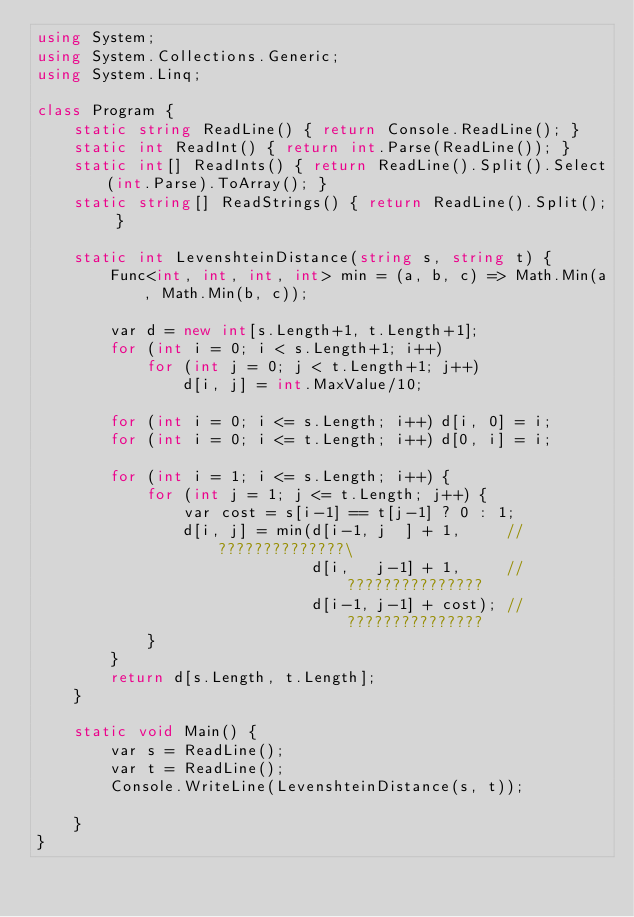<code> <loc_0><loc_0><loc_500><loc_500><_C#_>using System;
using System.Collections.Generic;
using System.Linq;

class Program {
    static string ReadLine() { return Console.ReadLine(); }
    static int ReadInt() { return int.Parse(ReadLine()); }
    static int[] ReadInts() { return ReadLine().Split().Select(int.Parse).ToArray(); }
    static string[] ReadStrings() { return ReadLine().Split(); }

    static int LevenshteinDistance(string s, string t) {
        Func<int, int, int, int> min = (a, b, c) => Math.Min(a, Math.Min(b, c));

        var d = new int[s.Length+1, t.Length+1];
        for (int i = 0; i < s.Length+1; i++)
            for (int j = 0; j < t.Length+1; j++)
                d[i, j] = int.MaxValue/10;

        for (int i = 0; i <= s.Length; i++) d[i, 0] = i;
        for (int i = 0; i <= t.Length; i++) d[0, i] = i;

        for (int i = 1; i <= s.Length; i++) {
            for (int j = 1; j <= t.Length; j++) {
                var cost = s[i-1] == t[j-1] ? 0 : 1;
                d[i, j] = min(d[i-1, j  ] + 1,     // ??????????????\
                              d[i,   j-1] + 1,     // ???????????????
                              d[i-1, j-1] + cost); // ???????????????
            }
        }
        return d[s.Length, t.Length];
    }

    static void Main() {
        var s = ReadLine();
        var t = ReadLine();
        Console.WriteLine(LevenshteinDistance(s, t));

    }
}</code> 